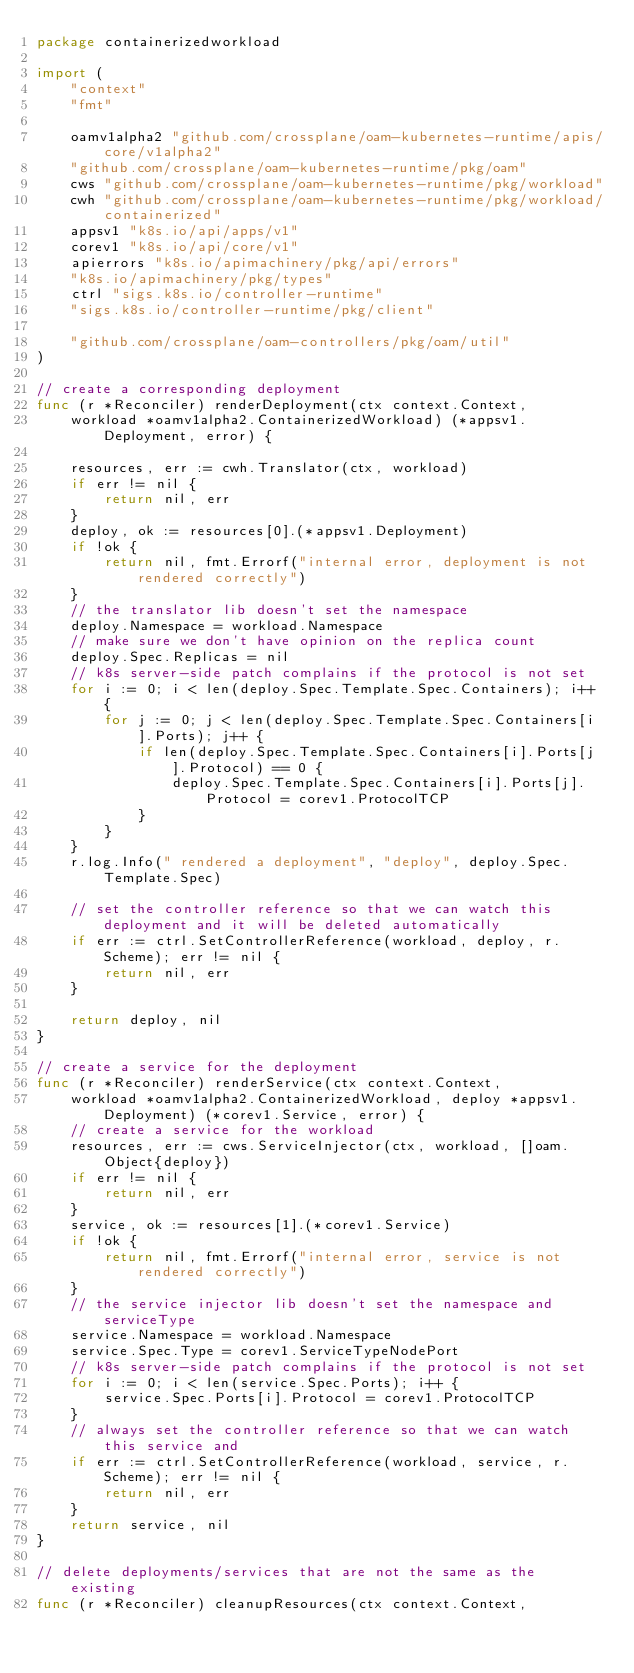Convert code to text. <code><loc_0><loc_0><loc_500><loc_500><_Go_>package containerizedworkload

import (
	"context"
	"fmt"

	oamv1alpha2 "github.com/crossplane/oam-kubernetes-runtime/apis/core/v1alpha2"
	"github.com/crossplane/oam-kubernetes-runtime/pkg/oam"
	cws "github.com/crossplane/oam-kubernetes-runtime/pkg/workload"
	cwh "github.com/crossplane/oam-kubernetes-runtime/pkg/workload/containerized"
	appsv1 "k8s.io/api/apps/v1"
	corev1 "k8s.io/api/core/v1"
	apierrors "k8s.io/apimachinery/pkg/api/errors"
	"k8s.io/apimachinery/pkg/types"
	ctrl "sigs.k8s.io/controller-runtime"
	"sigs.k8s.io/controller-runtime/pkg/client"

	"github.com/crossplane/oam-controllers/pkg/oam/util"
)

// create a corresponding deployment
func (r *Reconciler) renderDeployment(ctx context.Context,
	workload *oamv1alpha2.ContainerizedWorkload) (*appsv1.Deployment, error) {

	resources, err := cwh.Translator(ctx, workload)
	if err != nil {
		return nil, err
	}
	deploy, ok := resources[0].(*appsv1.Deployment)
	if !ok {
		return nil, fmt.Errorf("internal error, deployment is not rendered correctly")
	}
	// the translator lib doesn't set the namespace
	deploy.Namespace = workload.Namespace
	// make sure we don't have opinion on the replica count
	deploy.Spec.Replicas = nil
	// k8s server-side patch complains if the protocol is not set
	for i := 0; i < len(deploy.Spec.Template.Spec.Containers); i++ {
		for j := 0; j < len(deploy.Spec.Template.Spec.Containers[i].Ports); j++ {
			if len(deploy.Spec.Template.Spec.Containers[i].Ports[j].Protocol) == 0 {
				deploy.Spec.Template.Spec.Containers[i].Ports[j].Protocol = corev1.ProtocolTCP
			}
		}
	}
	r.log.Info(" rendered a deployment", "deploy", deploy.Spec.Template.Spec)

	// set the controller reference so that we can watch this deployment and it will be deleted automatically
	if err := ctrl.SetControllerReference(workload, deploy, r.Scheme); err != nil {
		return nil, err
	}

	return deploy, nil
}

// create a service for the deployment
func (r *Reconciler) renderService(ctx context.Context,
	workload *oamv1alpha2.ContainerizedWorkload, deploy *appsv1.Deployment) (*corev1.Service, error) {
	// create a service for the workload
	resources, err := cws.ServiceInjector(ctx, workload, []oam.Object{deploy})
	if err != nil {
		return nil, err
	}
	service, ok := resources[1].(*corev1.Service)
	if !ok {
		return nil, fmt.Errorf("internal error, service is not rendered correctly")
	}
	// the service injector lib doesn't set the namespace and serviceType
	service.Namespace = workload.Namespace
	service.Spec.Type = corev1.ServiceTypeNodePort
	// k8s server-side patch complains if the protocol is not set
	for i := 0; i < len(service.Spec.Ports); i++ {
		service.Spec.Ports[i].Protocol = corev1.ProtocolTCP
	}
	// always set the controller reference so that we can watch this service and
	if err := ctrl.SetControllerReference(workload, service, r.Scheme); err != nil {
		return nil, err
	}
	return service, nil
}

// delete deployments/services that are not the same as the existing
func (r *Reconciler) cleanupResources(ctx context.Context,</code> 